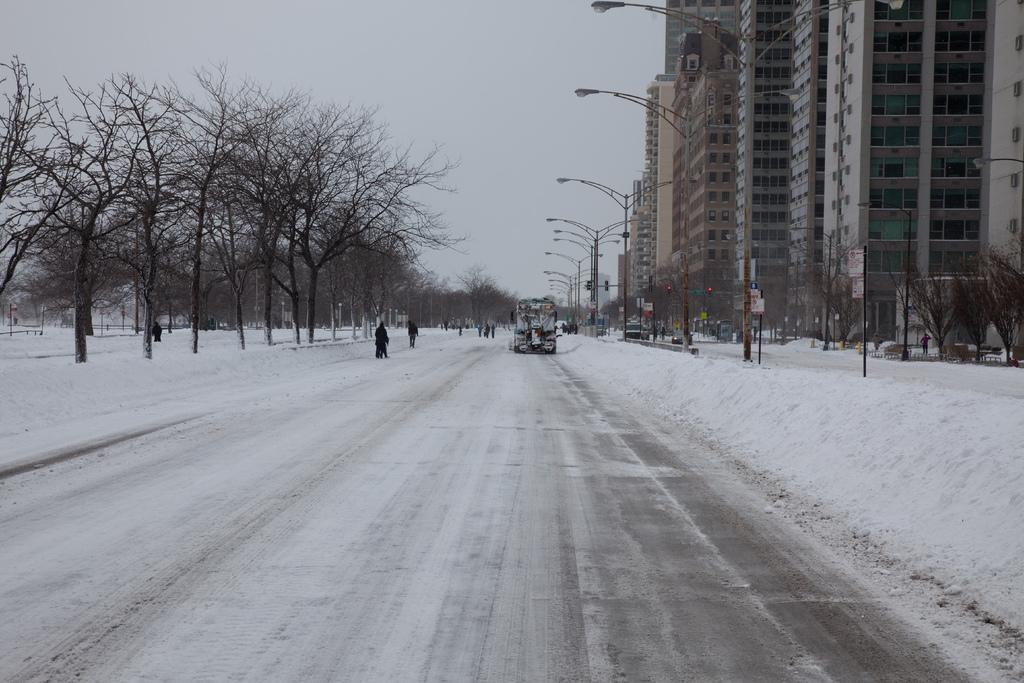What type of structures can be seen in the image? There are buildings in the image. What type of lighting is present in the image? There are pole lights in the image. What type of vegetation is present in the image? There are trees in the image. What are the people in the image doing? There are people walking in the image. What is the condition of the ground in the image? There is snow on the ground in the image. What type of transportation is moving in the image? There is a vehicle moving on the road in the image. What is the weather like in the image? The sky is cloudy in the image. Can you see the moon in the image? There is no moon visible in the image; the sky is cloudy. What type of ball is being played with in the image? There is no ball present in the image. 